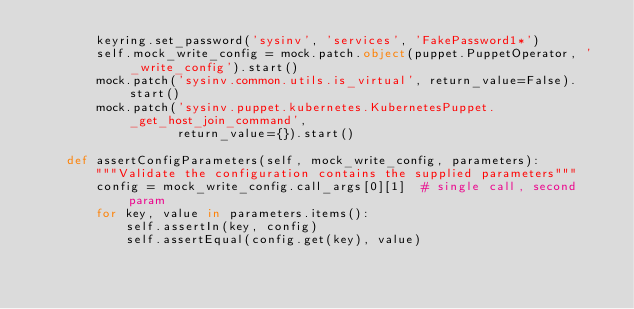<code> <loc_0><loc_0><loc_500><loc_500><_Python_>        keyring.set_password('sysinv', 'services', 'FakePassword1*')
        self.mock_write_config = mock.patch.object(puppet.PuppetOperator, '_write_config').start()
        mock.patch('sysinv.common.utils.is_virtual', return_value=False).start()
        mock.patch('sysinv.puppet.kubernetes.KubernetesPuppet._get_host_join_command',
                   return_value={}).start()

    def assertConfigParameters(self, mock_write_config, parameters):
        """Validate the configuration contains the supplied parameters"""
        config = mock_write_config.call_args[0][1]  # single call, second param
        for key, value in parameters.items():
            self.assertIn(key, config)
            self.assertEqual(config.get(key), value)
</code> 